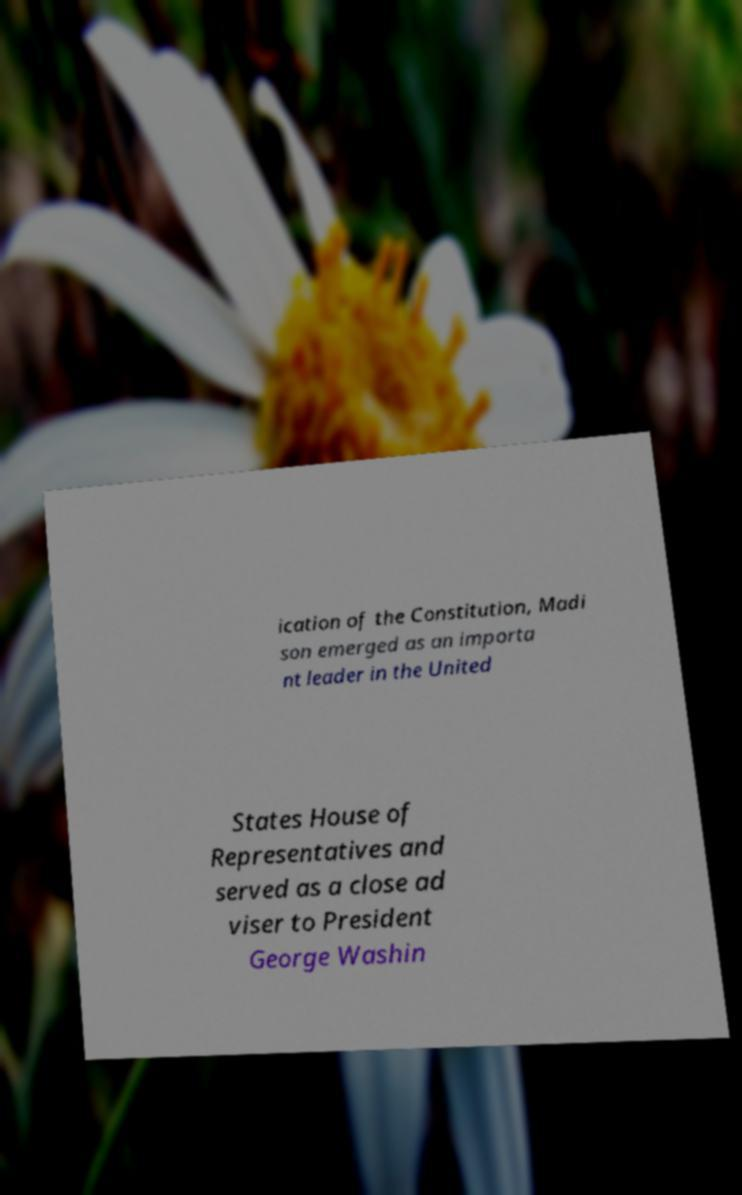There's text embedded in this image that I need extracted. Can you transcribe it verbatim? ication of the Constitution, Madi son emerged as an importa nt leader in the United States House of Representatives and served as a close ad viser to President George Washin 